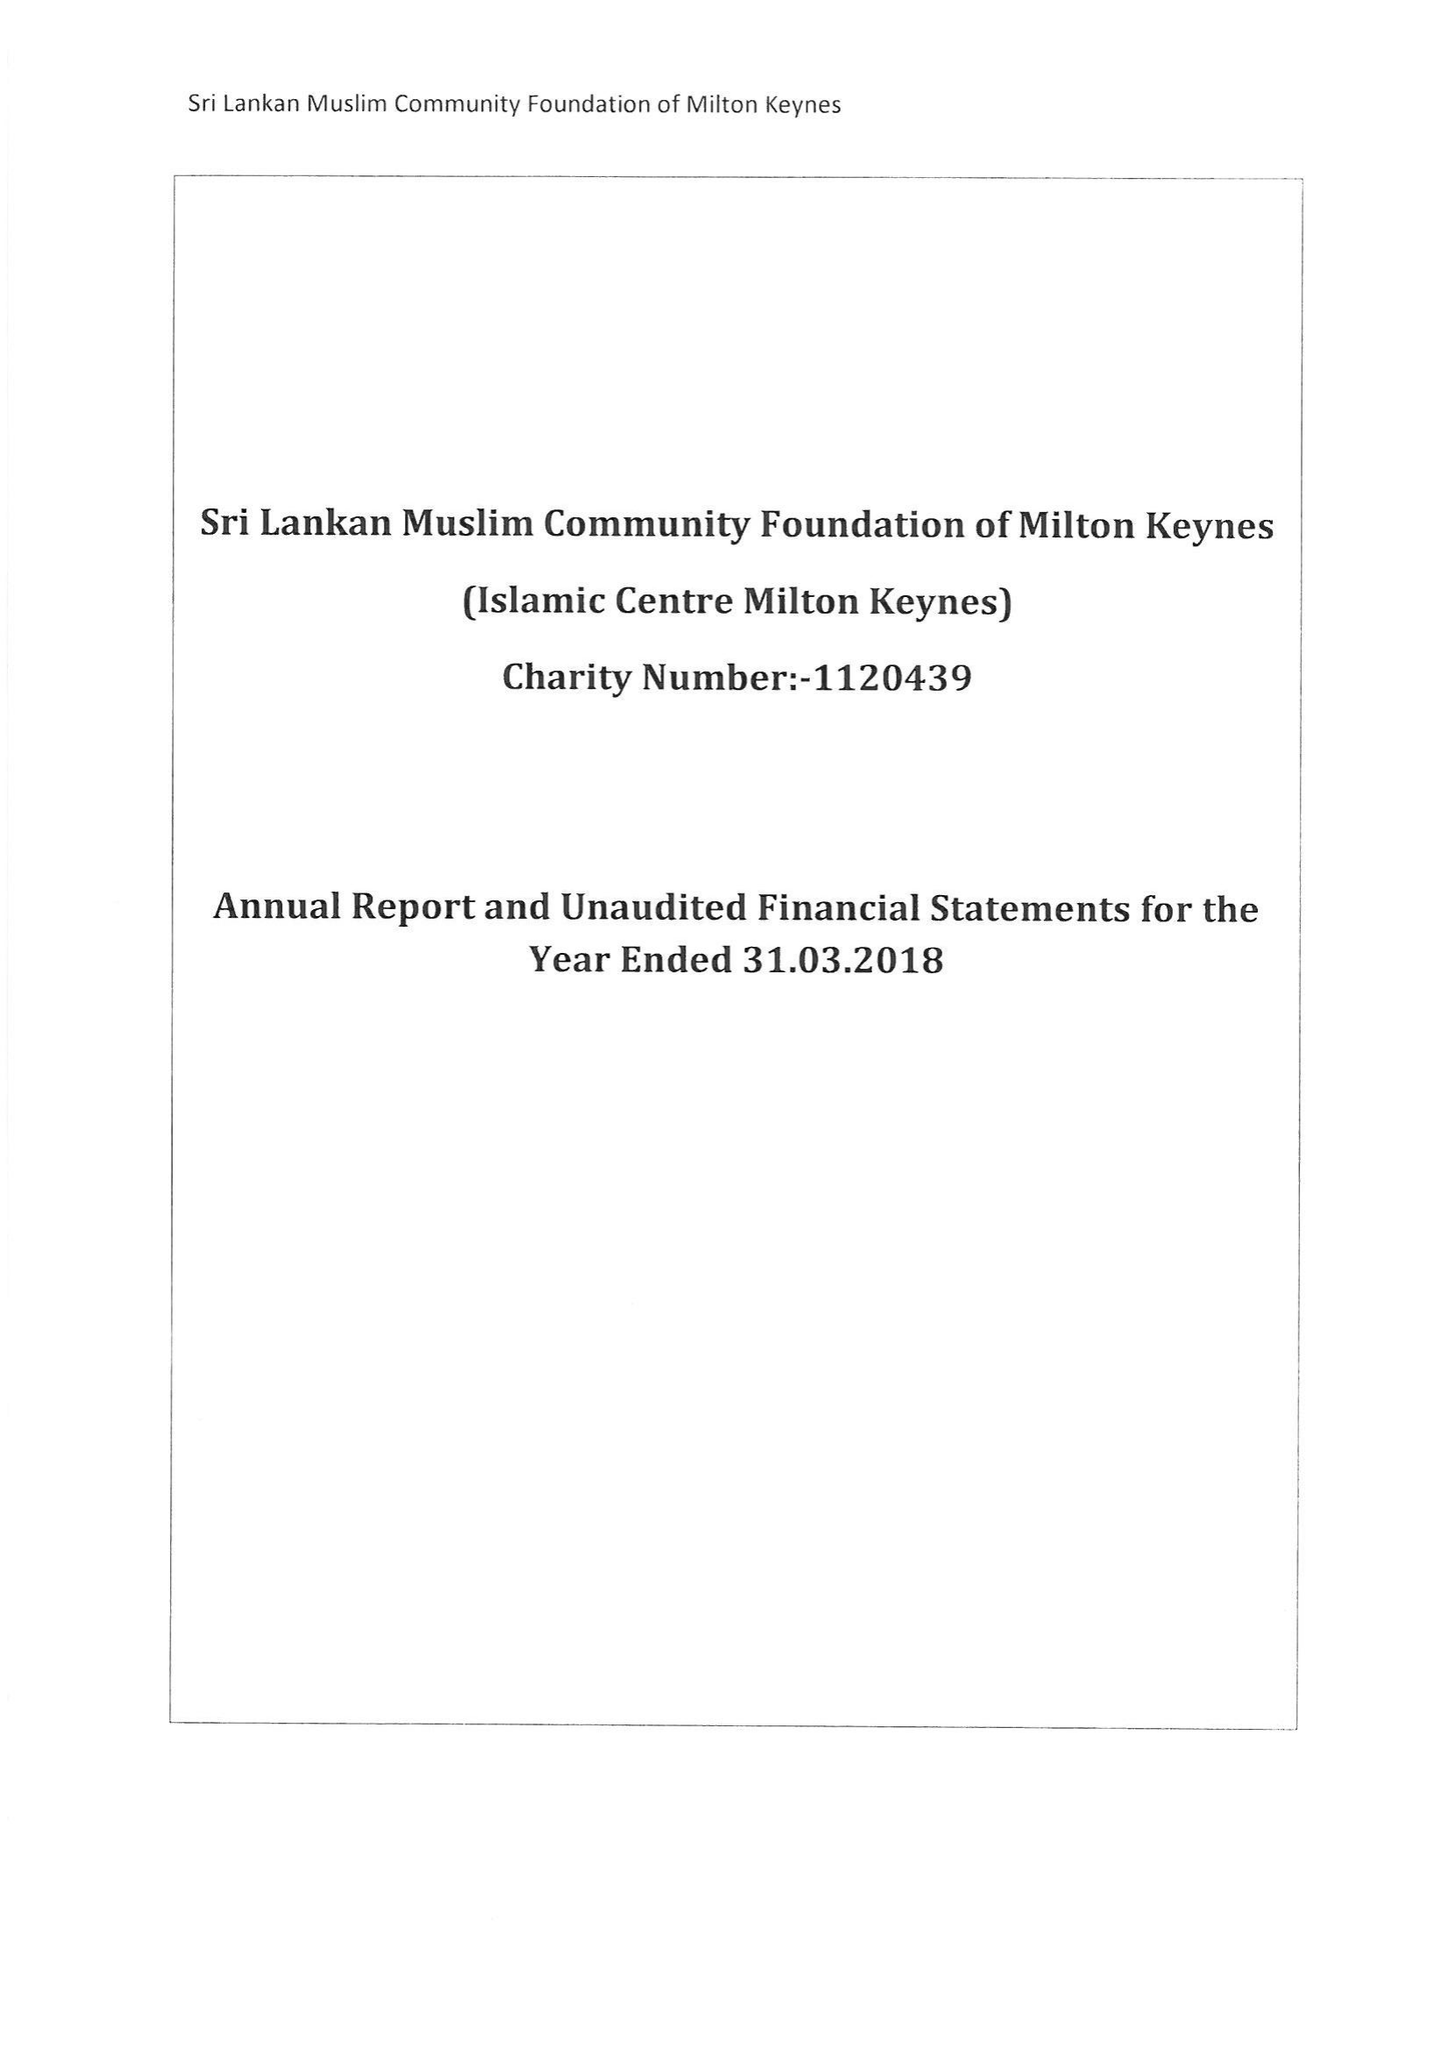What is the value for the charity_name?
Answer the question using a single word or phrase. Sri Lankan Muslim Community Foundation Of Milton Keynes 